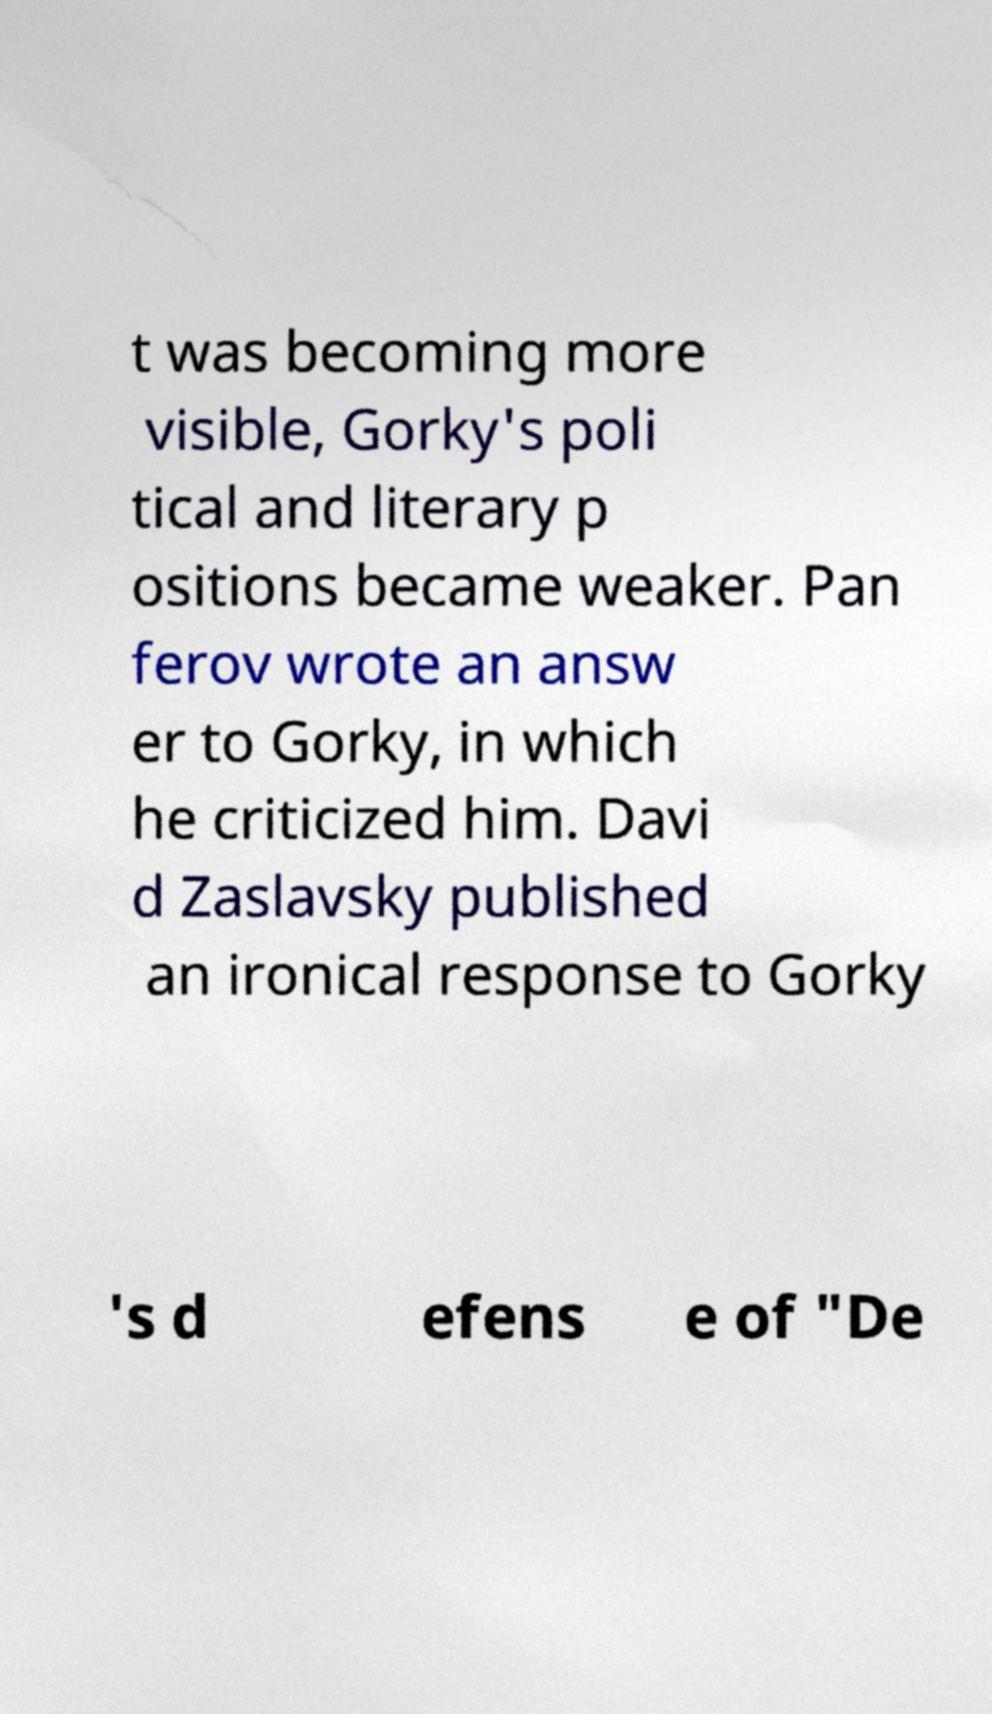Could you extract and type out the text from this image? t was becoming more visible, Gorky's poli tical and literary p ositions became weaker. Pan ferov wrote an answ er to Gorky, in which he criticized him. Davi d Zaslavsky published an ironical response to Gorky 's d efens e of "De 